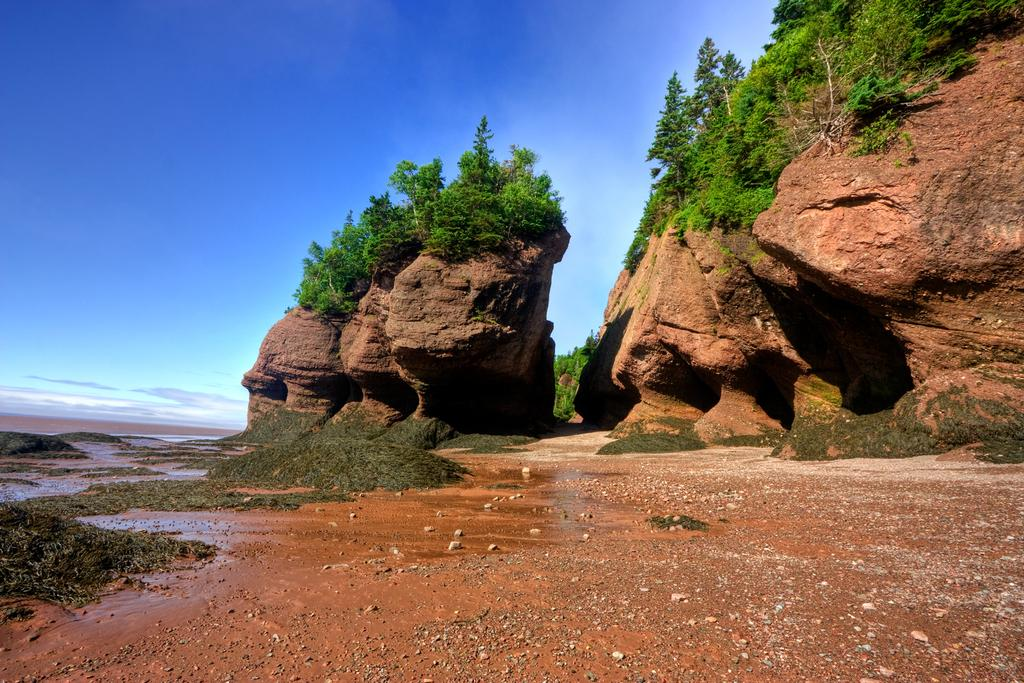What type of terrain is depicted in the image? The image contains mud, grass, trees, and rocks, indicating a natural outdoor setting. What type of vegetation can be seen in the image? There are trees and grass visible in the image. What type of geological feature is present in the image? There are rocks in the image. What is visible in the sky at the top of the image? There are clouds in the sky at the top of the image. Can you see a tiger walking on the road in the image? There is no road or tiger present in the image. What type of bear can be seen hiding behind the trees in the image? There are no bears present in the image; it features mud, grass, trees, rocks, and clouds. 